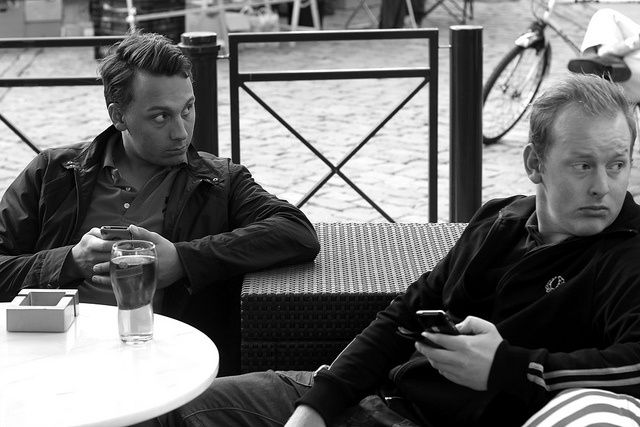Describe the objects in this image and their specific colors. I can see people in black, gray, darkgray, and lightgray tones, people in black, gray, darkgray, and lightgray tones, dining table in black, white, darkgray, and dimgray tones, bicycle in black, lightgray, darkgray, and gray tones, and people in black, white, darkgray, and gray tones in this image. 